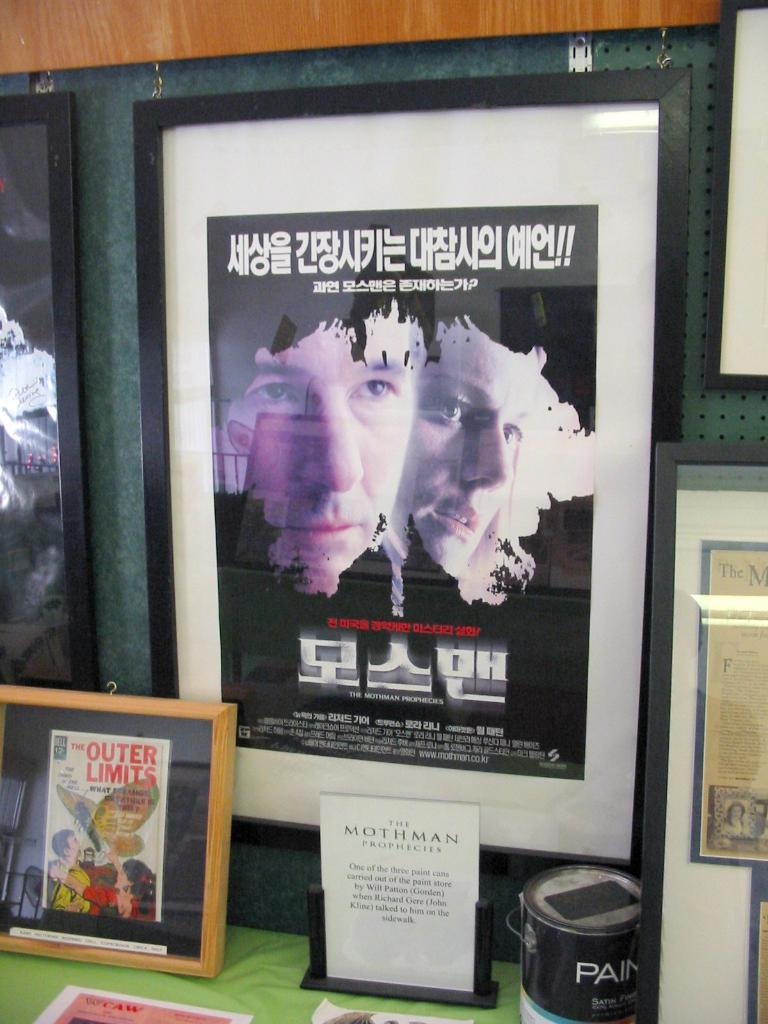<image>
Give a short and clear explanation of the subsequent image. a frame that has the outer limits in it 